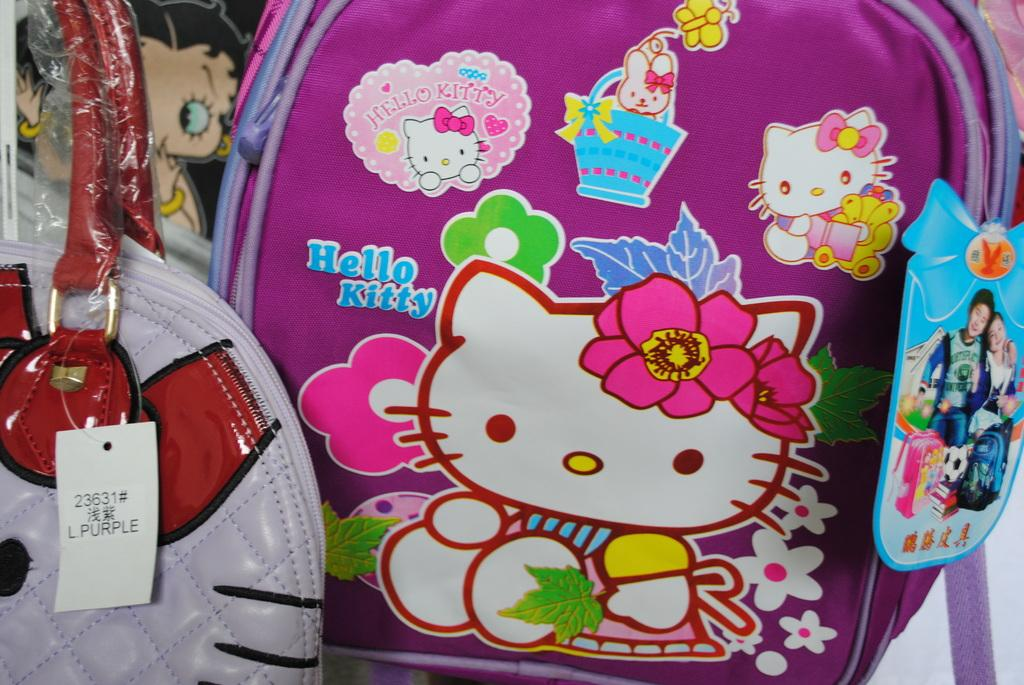What color is the bag that is visible in the image? There is a pink bag in the image. What is depicted on the pink bag? The pink bag has cartoons on it. Where is the other bag located in the image? There is a white and red bag on the left side of the image. Can you tell me what the girl is saying to the book in the image? There is no girl or book present in the image; it only features two bags. 